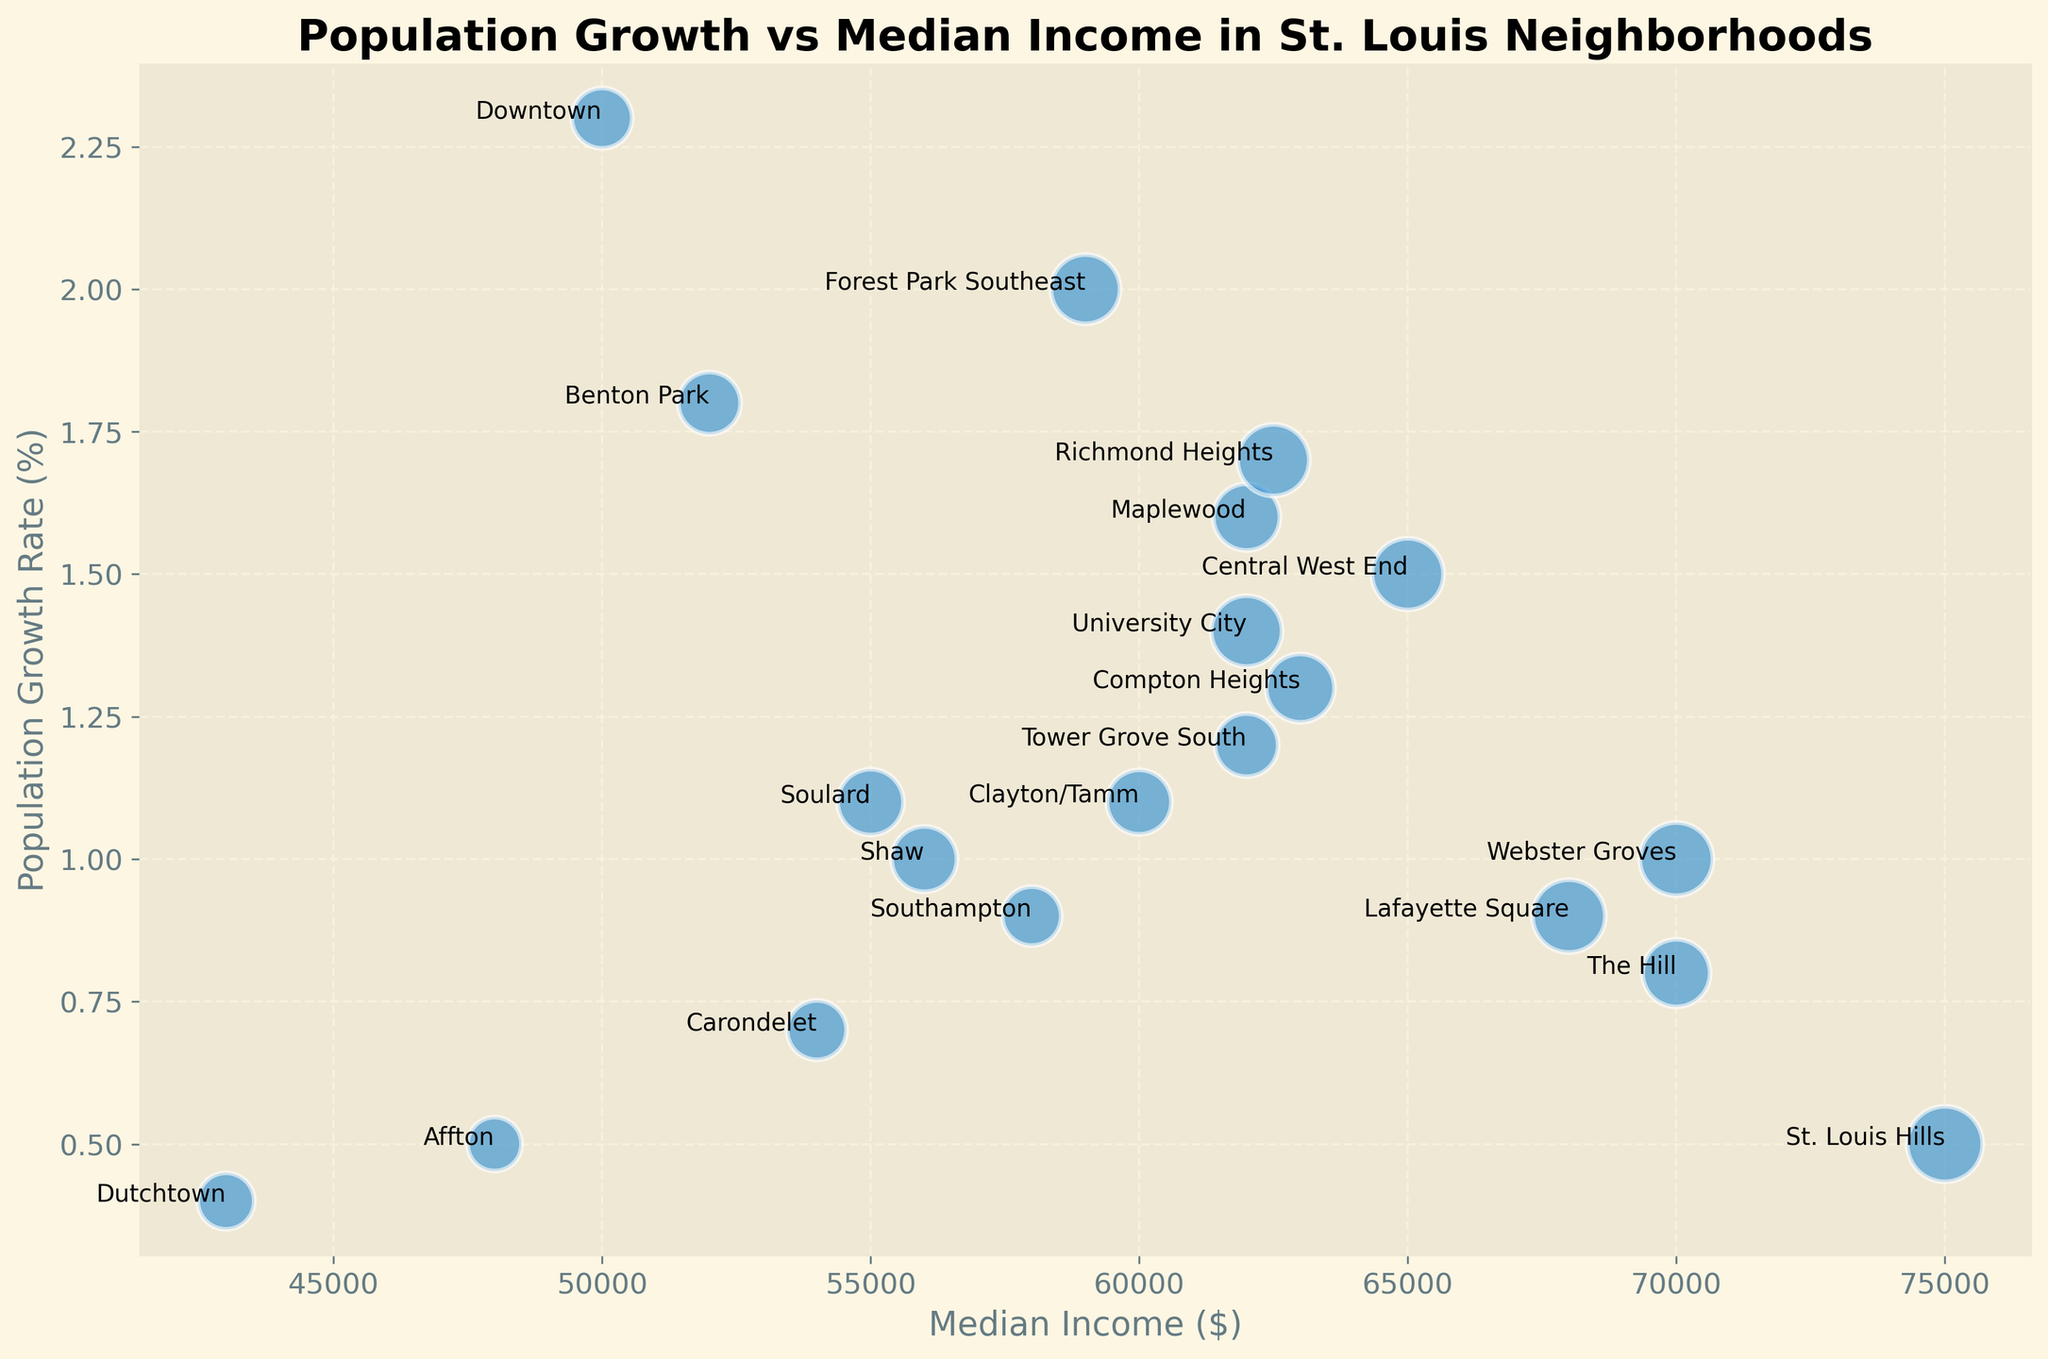Which neighborhood has the highest population growth rate? The neighborhood with the highest population growth rate is identified by the highest position on the y-axis. Looking at the figure, Downtown has the highest population growth rate.
Answer: Downtown What is the median income of the neighborhood with the lowest median housing price? The neighborhood with the lowest median housing price is identified by the smallest bubble size. This is Affton, with a median housing price of $255,000. The median income for Affton is $48,000.
Answer: $48,000 Which neighborhoods have population growth rates greater than 1.0% and median income greater than $60,000? To answer this, identify bubbles higher than the 1.0% horizontal line and to the right of $60,000 on the x-axis. These neighborhoods are Forest Park Southeast, Compton Heights, and Maplewood.
Answer: Forest Park Southeast, Compton Heights, Maplewood Compare the population growth rates of Central West End and Shaw. Which is higher? Compare the vertical positions of the bubbles labeled Central West End and Shaw along the y-axis. Central West End's growth rate is higher at 1.5% compared to Shaw's 1.0%.
Answer: Central West End What is the difference in median housing prices between St. Louis Hills and Benton Park? The median housing prices for St. Louis Hills and Benton Park are $500,000 and $340,000, respectively. The difference is $500,000 - $340,000 = $160,000.
Answer: $160,000 Which neighborhood has the highest median housing price and what is its population growth rate? The neighborhood with the highest median housing price, represented by the largest bubble, is St. Louis Hills with a housing price of $500,000. Its population growth rate is 0.5%.
Answer: St. Louis Hills, 0.5% Between The Hill and Lafayette Square, which has a higher median income and by how much? The median incomes are $70,000 for The Hill and $68,000 for Lafayette Square. The difference is $70,000 - $68,000 = $2,000.
Answer: The Hill, $2,000 Identify three neighborhoods with population growth rates between 1.0% and 1.5%. Look at neighborhoods whose bubbles lie between 1.0% and 1.5% on the y-axis. These neighborhoods are University City, Maplewood, and Central West End.
Answer: University City, Maplewood, Central West End What is the combined population growth rate of Tower Grove South, The Hill, and Webster Groves? The growth rates are 1.2%, 0.8%, and 1.0%, respectively. The combined rate is 1.2% + 0.8% + 1.0% = 3.0%.
Answer: 3.0% Which neighborhood has the closest median income to the average median income of all neighborhoods? Calculate the average median income: (65000 + 50000 + 55000 + 70000 + 62000 + 68000 + 56000 + 75000 + 52000 + 54000 + 59000 + 43000 + 63000 + 60000 + 58000 + 62000 + 62000 + 70000 + 62500 + 48000) / 20 = $60500. Identify the neighborhood with a median income closest to $60,500, which is Clayton/Tamm with a median income of $60,000.
Answer: Clayton/Tamm 